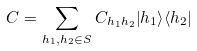Convert formula to latex. <formula><loc_0><loc_0><loc_500><loc_500>C = \sum _ { h _ { 1 } , h _ { 2 } \in S } C _ { h _ { 1 } h _ { 2 } } { \left | h _ { 1 } \right \rangle } { \left \langle h _ { 2 } \right | }</formula> 